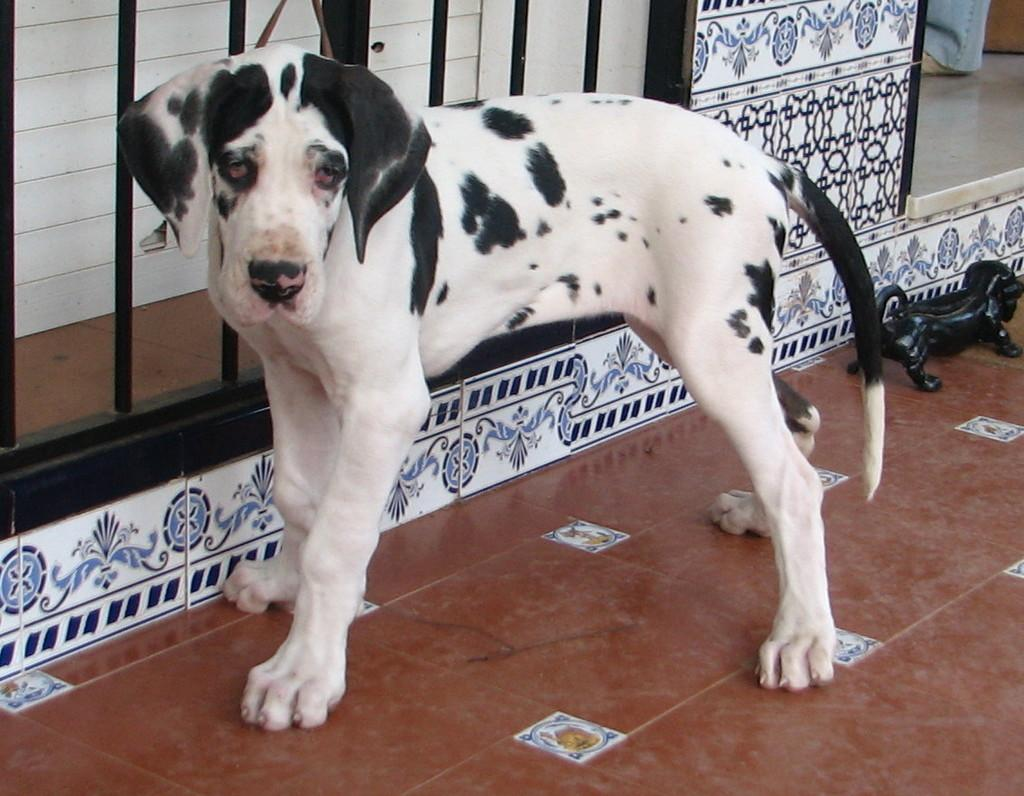What type of animal can be seen in the image? There is a dog in the image. What object is on the floor in the image? There is a toy on the floor in the image. Can you describe any part of a person in the image? A person's leg is visible in the image. What color is the wall in the image? There is a white wall in the image. What type of structure is present in the image? There is a black gate in the image. What is the title of the book the dog is reading in the image? There is no book or reading activity depicted in the image. 